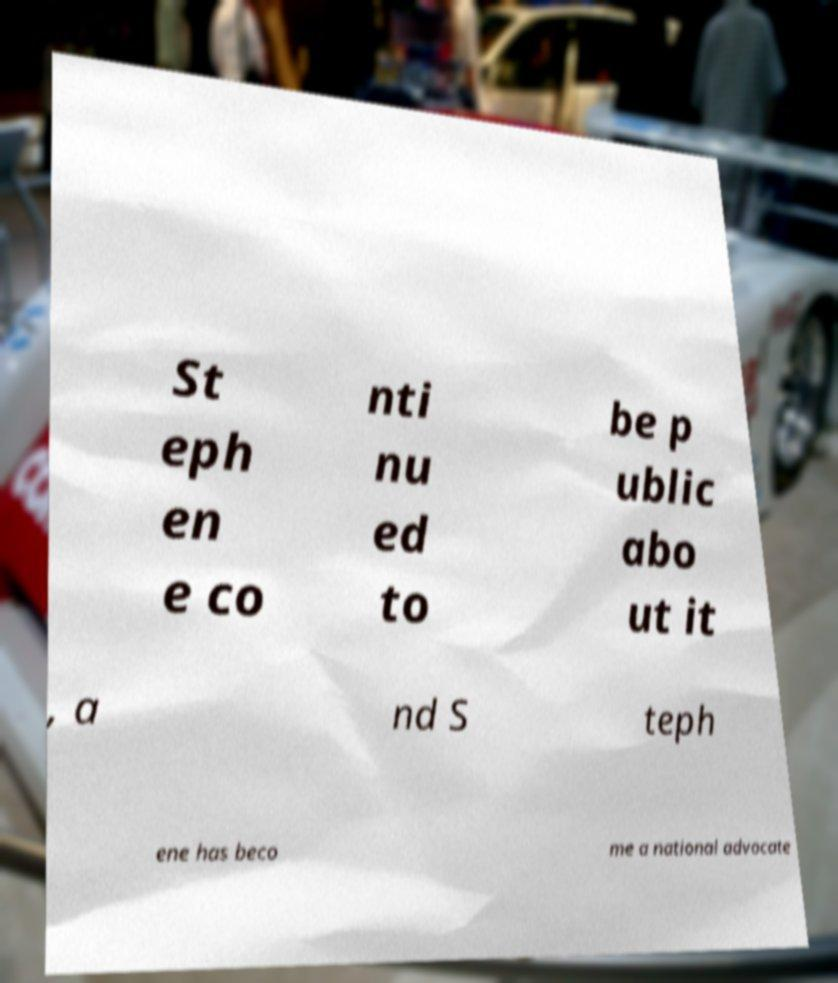I need the written content from this picture converted into text. Can you do that? St eph en e co nti nu ed to be p ublic abo ut it , a nd S teph ene has beco me a national advocate 